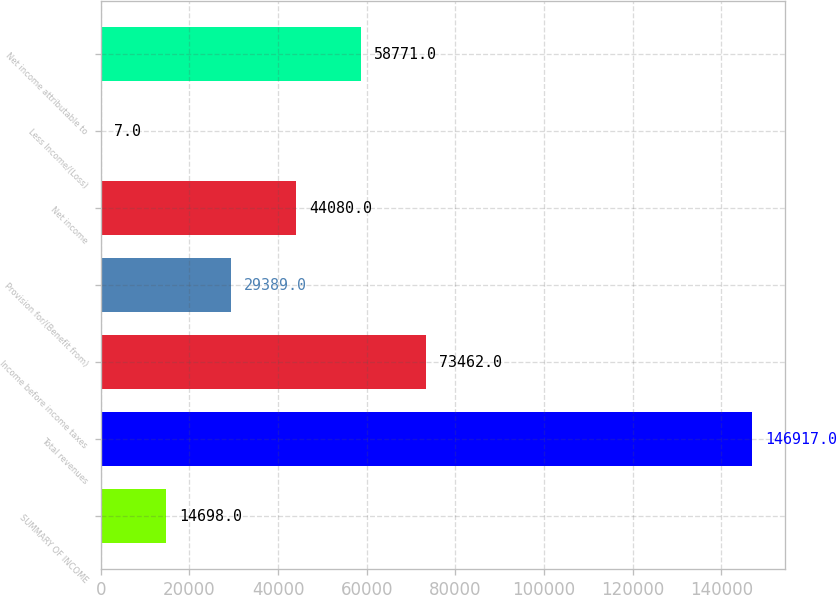Convert chart to OTSL. <chart><loc_0><loc_0><loc_500><loc_500><bar_chart><fcel>SUMMARY OF INCOME<fcel>Total revenues<fcel>Income before income taxes<fcel>Provision for/(Benefit from)<fcel>Net income<fcel>Less Income/(Loss)<fcel>Net income attributable to<nl><fcel>14698<fcel>146917<fcel>73462<fcel>29389<fcel>44080<fcel>7<fcel>58771<nl></chart> 